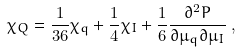<formula> <loc_0><loc_0><loc_500><loc_500>\chi _ { Q } = \frac { 1 } { 3 6 } \chi _ { q } + \frac { 1 } { 4 } \chi _ { I } + \frac { 1 } { 6 } { \frac { \partial ^ { 2 } P } { \partial \mu _ { q } \partial \mu _ { I } } } \, ,</formula> 